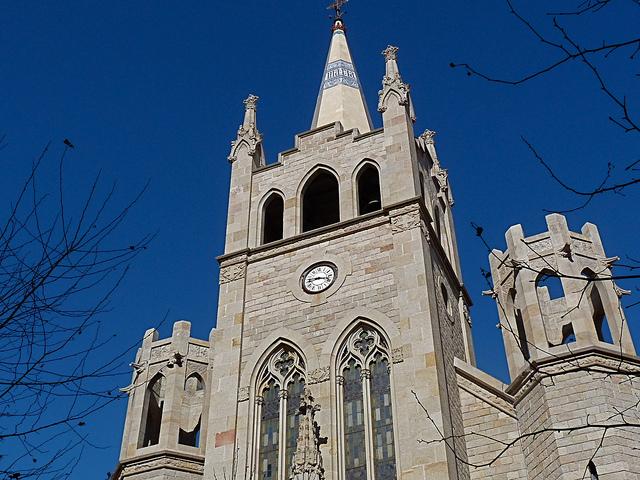What time does the clock say?
Write a very short answer. 3:45. What time is on the clock tower?
Concise answer only. 3:45. Which side of the tower is darker?
Give a very brief answer. Right. What religion is practiced here?
Be succinct. Catholic. Is this a religious building?
Be succinct. Yes. How many clocks are on the building?
Give a very brief answer. 1. 